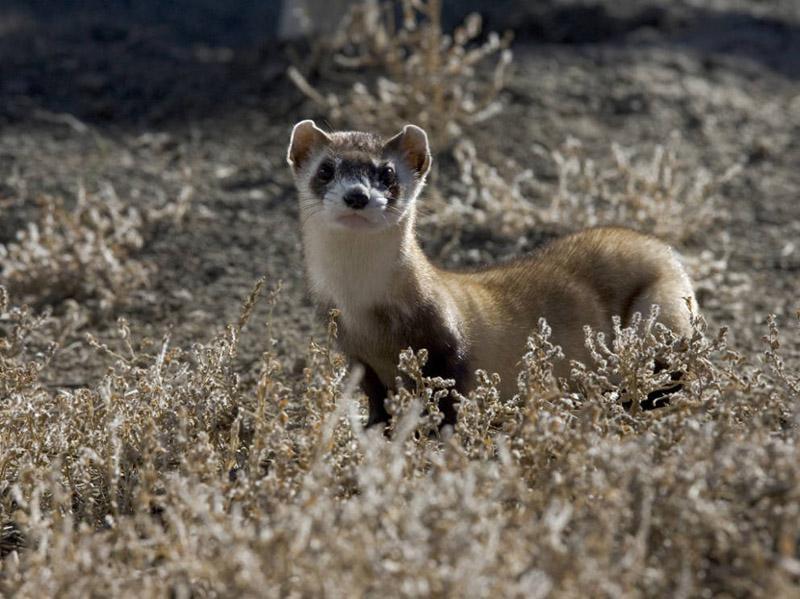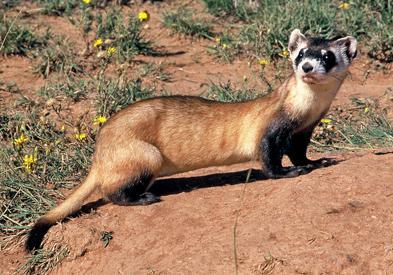The first image is the image on the left, the second image is the image on the right. Examine the images to the left and right. Is the description "There are two black footed ferrets standing outside in the center of the image." accurate? Answer yes or no. Yes. 